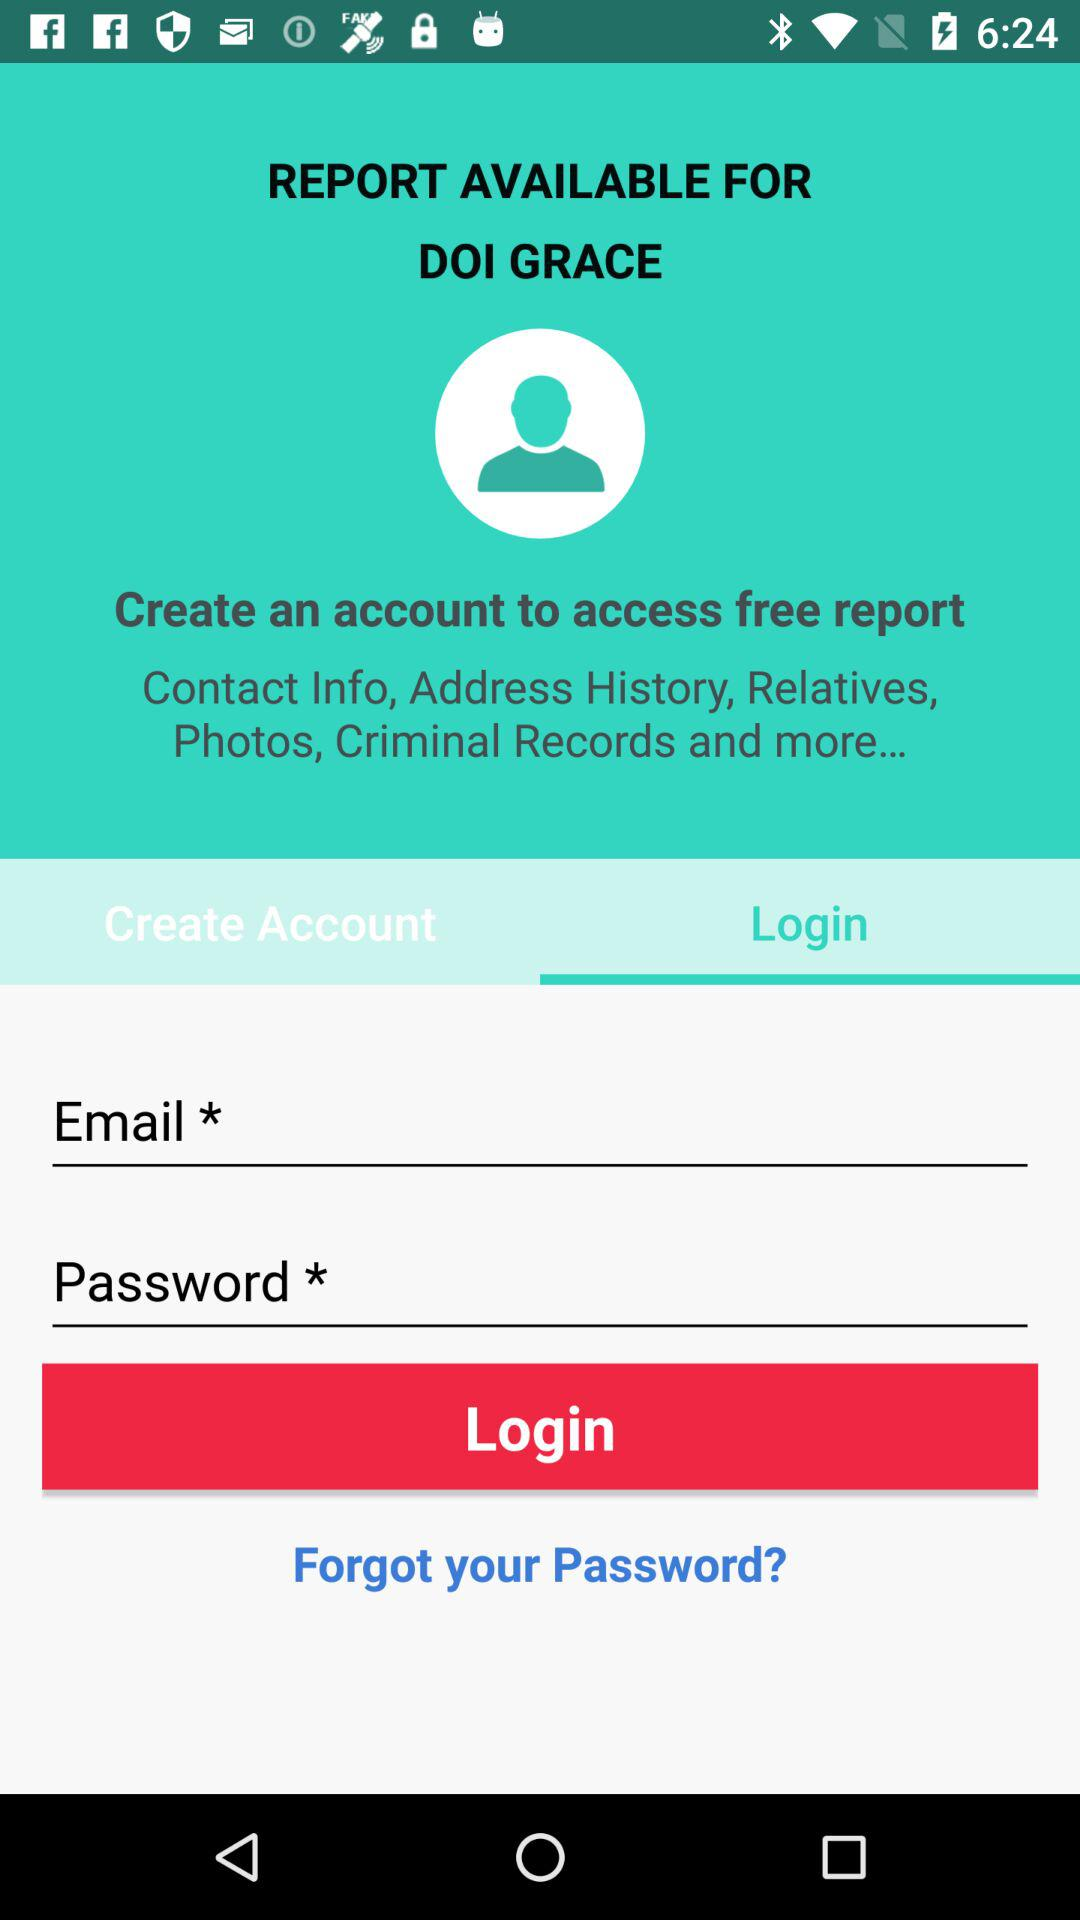What is the application name? The application name is "DOI". 